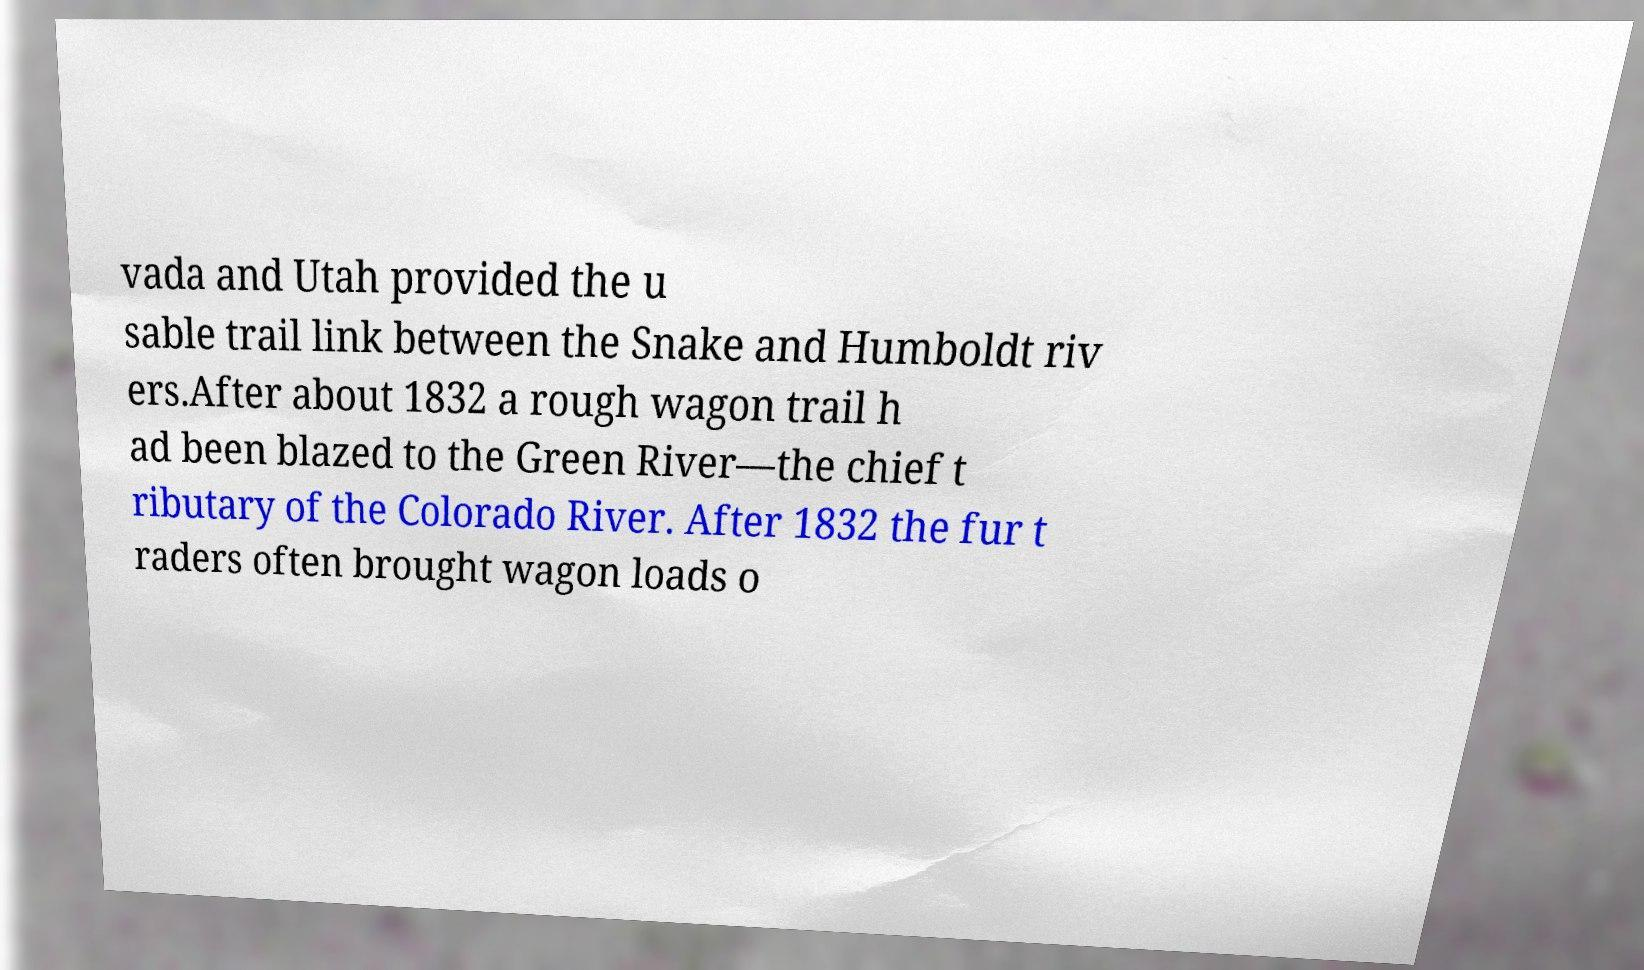Could you extract and type out the text from this image? vada and Utah provided the u sable trail link between the Snake and Humboldt riv ers.After about 1832 a rough wagon trail h ad been blazed to the Green River—the chief t ributary of the Colorado River. After 1832 the fur t raders often brought wagon loads o 